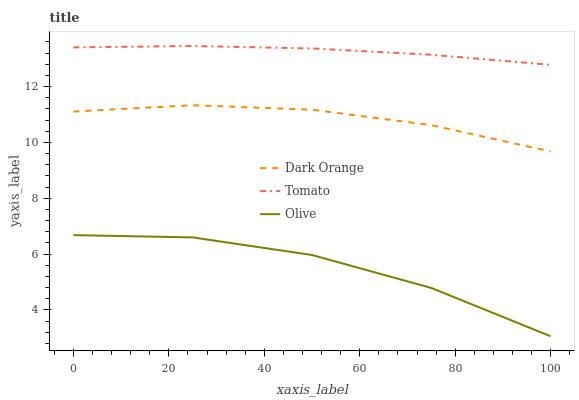Does Olive have the minimum area under the curve?
Answer yes or no. Yes. Does Tomato have the maximum area under the curve?
Answer yes or no. Yes. Does Dark Orange have the minimum area under the curve?
Answer yes or no. No. Does Dark Orange have the maximum area under the curve?
Answer yes or no. No. Is Tomato the smoothest?
Answer yes or no. Yes. Is Olive the roughest?
Answer yes or no. Yes. Is Dark Orange the smoothest?
Answer yes or no. No. Is Dark Orange the roughest?
Answer yes or no. No. Does Olive have the lowest value?
Answer yes or no. Yes. Does Dark Orange have the lowest value?
Answer yes or no. No. Does Tomato have the highest value?
Answer yes or no. Yes. Does Dark Orange have the highest value?
Answer yes or no. No. Is Olive less than Tomato?
Answer yes or no. Yes. Is Tomato greater than Dark Orange?
Answer yes or no. Yes. Does Olive intersect Tomato?
Answer yes or no. No. 